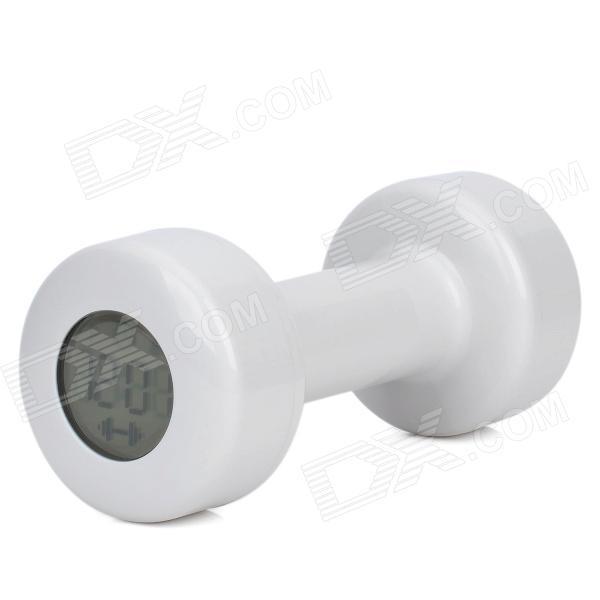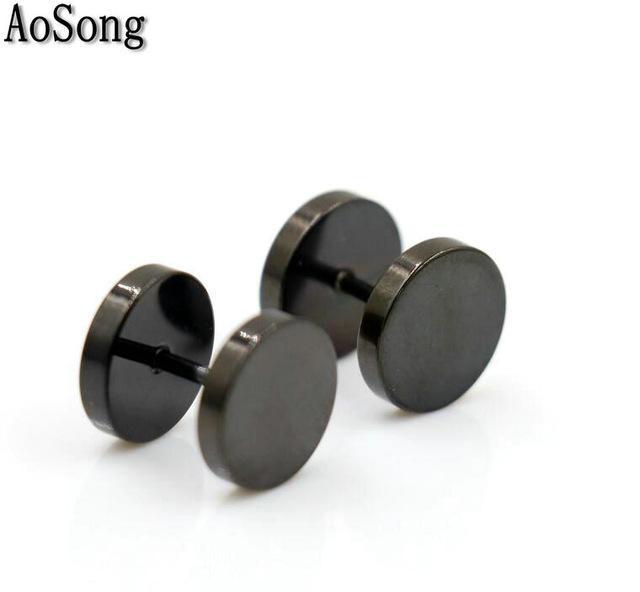The first image is the image on the left, the second image is the image on the right. Assess this claim about the two images: "There is one black free weight". Correct or not? Answer yes or no. No. The first image is the image on the left, the second image is the image on the right. Assess this claim about the two images: "AN image shows exactly one black dumbbell.". Correct or not? Answer yes or no. No. 